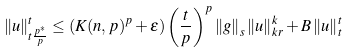<formula> <loc_0><loc_0><loc_500><loc_500>\left \| u \right \| _ { t \frac { p ^ { \ast } } { p } } ^ { t } \leq \left ( K ( n , p ) ^ { p } + \epsilon \right ) \left ( \frac { t } { p } \right ) ^ { p } \left \| g \right \| _ { s } \left \| u \right \| _ { k r } ^ { k } + B \left \| u \right \| _ { t } ^ { t }</formula> 